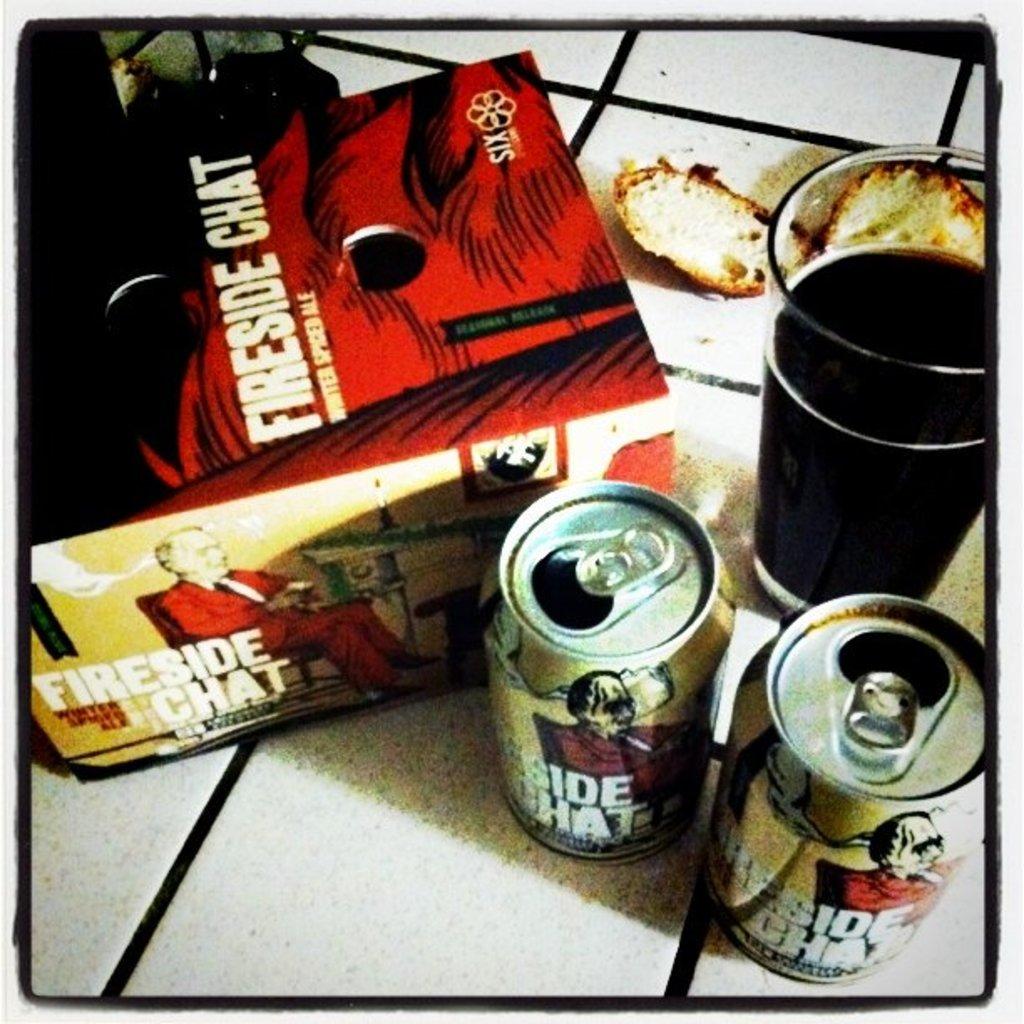What brand of drink is this?
Make the answer very short. Fireside chat. 